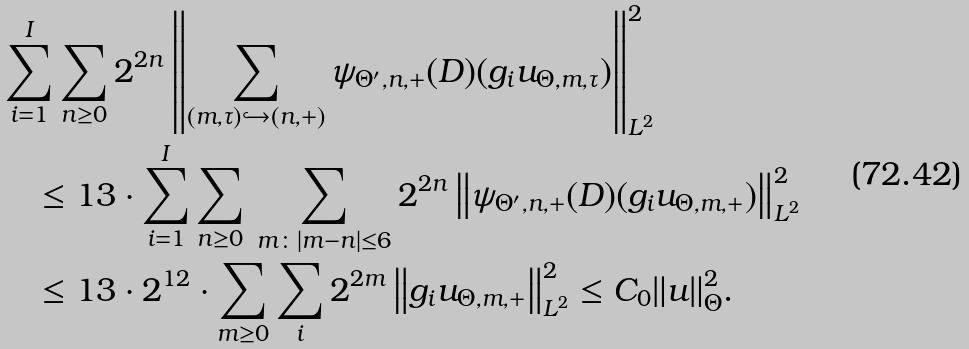<formula> <loc_0><loc_0><loc_500><loc_500>& \sum _ { i = 1 } ^ { I } \sum _ { n \geq 0 } 2 ^ { 2 n } \left \| \sum _ { ( m , \tau ) \hookrightarrow ( n , + ) } \psi _ { \Theta ^ { \prime } , n , + } ( D ) ( g _ { i } u _ { \Theta , m , \tau } ) \right \| _ { L ^ { 2 } } ^ { 2 } \\ & \quad \leq 1 3 \cdot \sum _ { i = 1 } ^ { I } \sum _ { n \geq 0 } \, \sum _ { m \colon | m - n | \leq 6 } 2 ^ { 2 n } \left \| \psi _ { \Theta ^ { \prime } , n , + } ( D ) ( g _ { i } u _ { \Theta , m , + } ) \right \| _ { L ^ { 2 } } ^ { 2 } \\ & \quad \leq 1 3 \cdot 2 ^ { 1 2 } \cdot \sum _ { m \geq 0 } \sum _ { i } 2 ^ { 2 m } \left \| g _ { i } u _ { \Theta , m , + } \right \| _ { L ^ { 2 } } ^ { 2 } \leq C _ { 0 } \| u \| _ { \Theta } ^ { 2 } .</formula> 